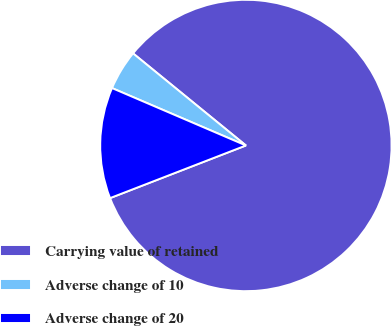Convert chart. <chart><loc_0><loc_0><loc_500><loc_500><pie_chart><fcel>Carrying value of retained<fcel>Adverse change of 10<fcel>Adverse change of 20<nl><fcel>83.23%<fcel>4.45%<fcel>12.33%<nl></chart> 